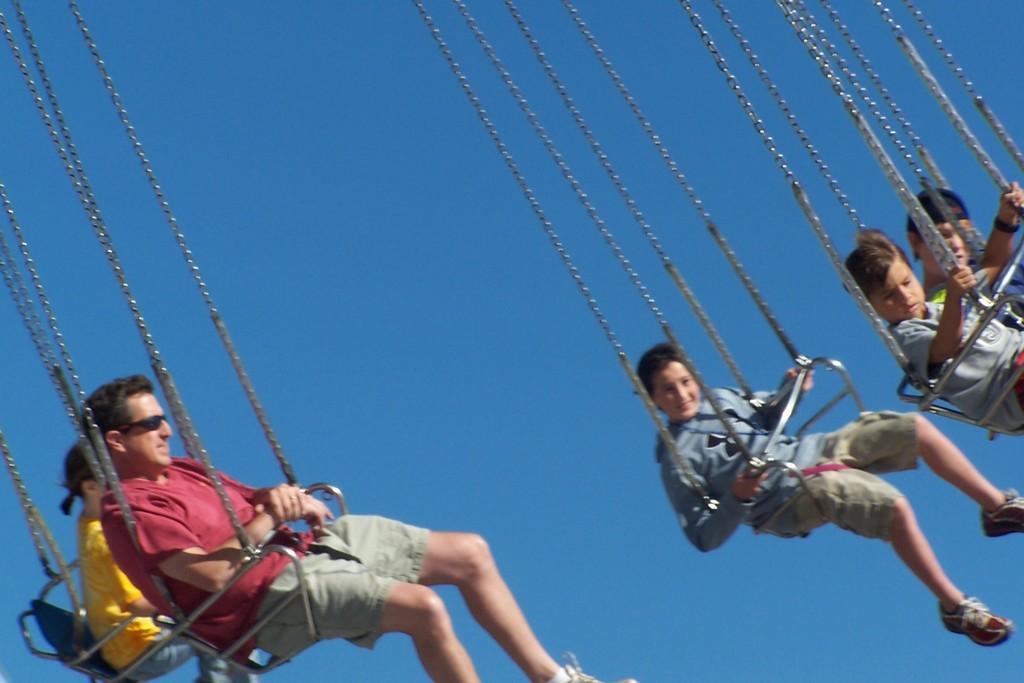Describe this image in one or two sentences. In this image we can see the people sitting on the chair swing rides and in the background, we can see the sky. 